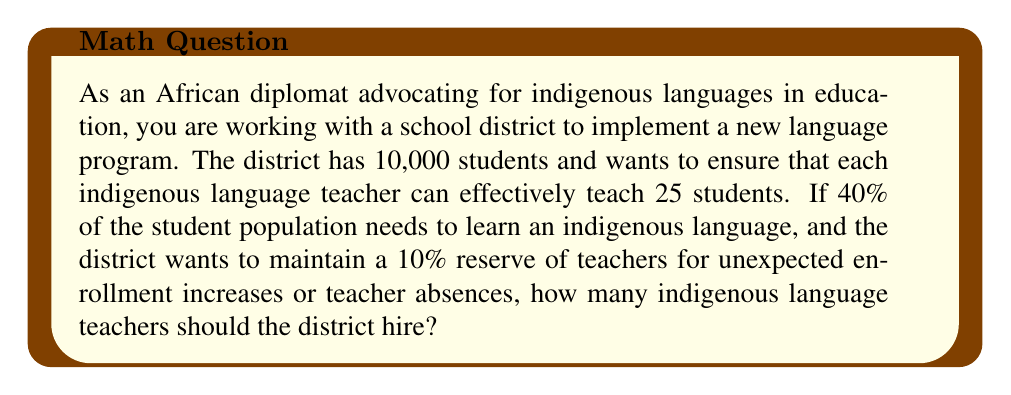Teach me how to tackle this problem. Let's approach this problem step by step:

1. Calculate the number of students needing indigenous language instruction:
   $$ 40\% \text{ of } 10,000 = 0.40 \times 10,000 = 4,000 \text{ students} $$

2. Calculate the base number of teachers needed:
   $$ \frac{\text{Number of students}}{\text{Students per teacher}} = \frac{4,000}{25} = 160 \text{ teachers} $$

3. Calculate the additional 10% reserve:
   $$ 10\% \text{ of } 160 = 0.10 \times 160 = 16 \text{ teachers} $$

4. Sum the base number and reserve:
   $$ 160 + 16 = 176 \text{ teachers} $$

Therefore, to accommodate the 4,000 students needing indigenous language instruction, maintain a student-to-teacher ratio of 25:1, and keep a 10% reserve, the district should hire 176 indigenous language teachers.
Answer: The optimal number of indigenous language teachers needed is 176. 